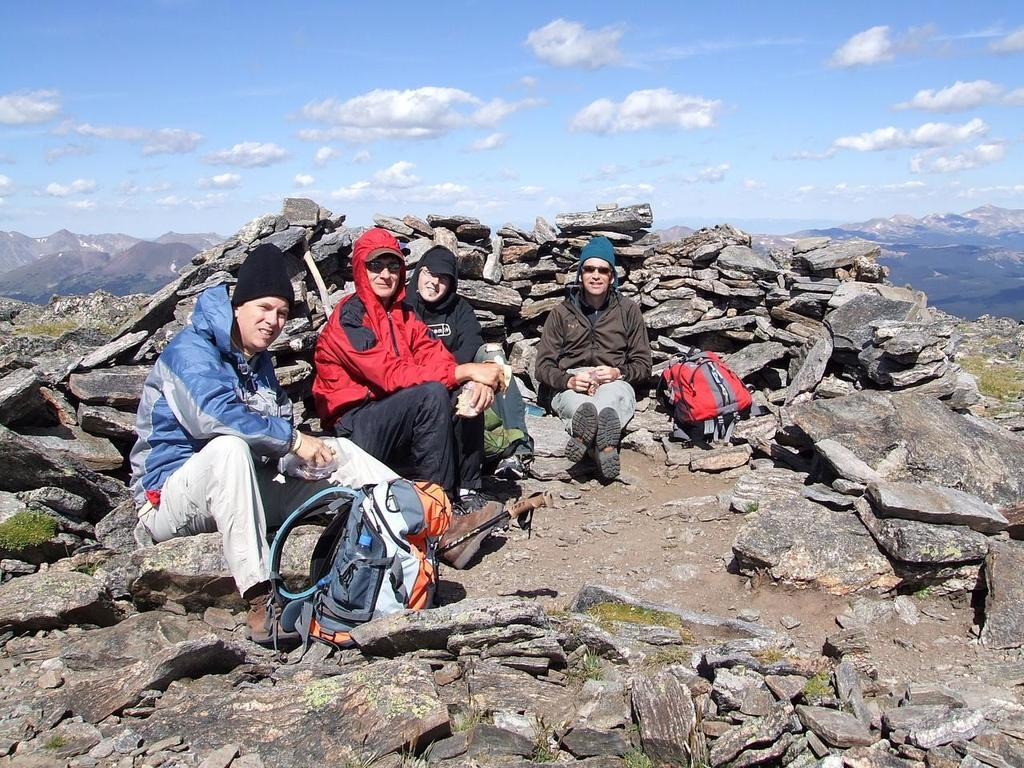What type of natural elements can be seen in the image? There are rocks in the image. What are the people in the image doing? The people are sitting in the front of the image. What items can be seen near the people? There are bags visible in the image. What is the liquid container in the image? There is a bottle in the image. What is visible in the background of the image? The sky is visible in the image, and clouds are present in the sky. What is the manager's role in the image? There is no manager present in the image. What type of stem can be seen growing from the rocks in the image? There are no stems visible in the image, as it features rocks and people sitting. 